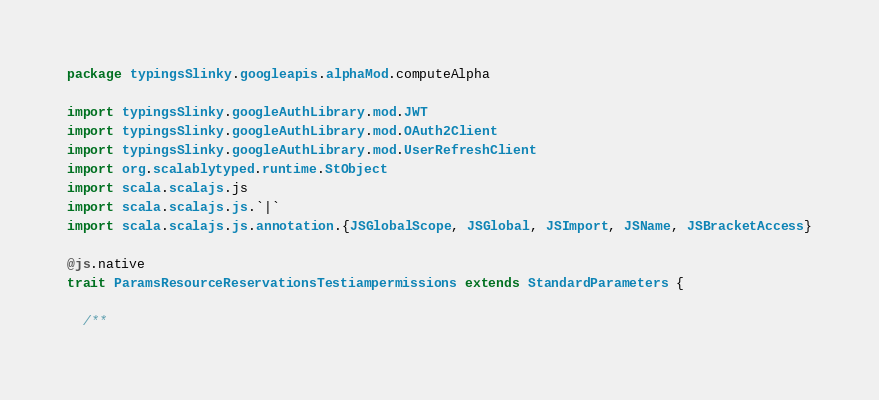<code> <loc_0><loc_0><loc_500><loc_500><_Scala_>package typingsSlinky.googleapis.alphaMod.computeAlpha

import typingsSlinky.googleAuthLibrary.mod.JWT
import typingsSlinky.googleAuthLibrary.mod.OAuth2Client
import typingsSlinky.googleAuthLibrary.mod.UserRefreshClient
import org.scalablytyped.runtime.StObject
import scala.scalajs.js
import scala.scalajs.js.`|`
import scala.scalajs.js.annotation.{JSGlobalScope, JSGlobal, JSImport, JSName, JSBracketAccess}

@js.native
trait ParamsResourceReservationsTestiampermissions extends StandardParameters {
  
  /**</code> 